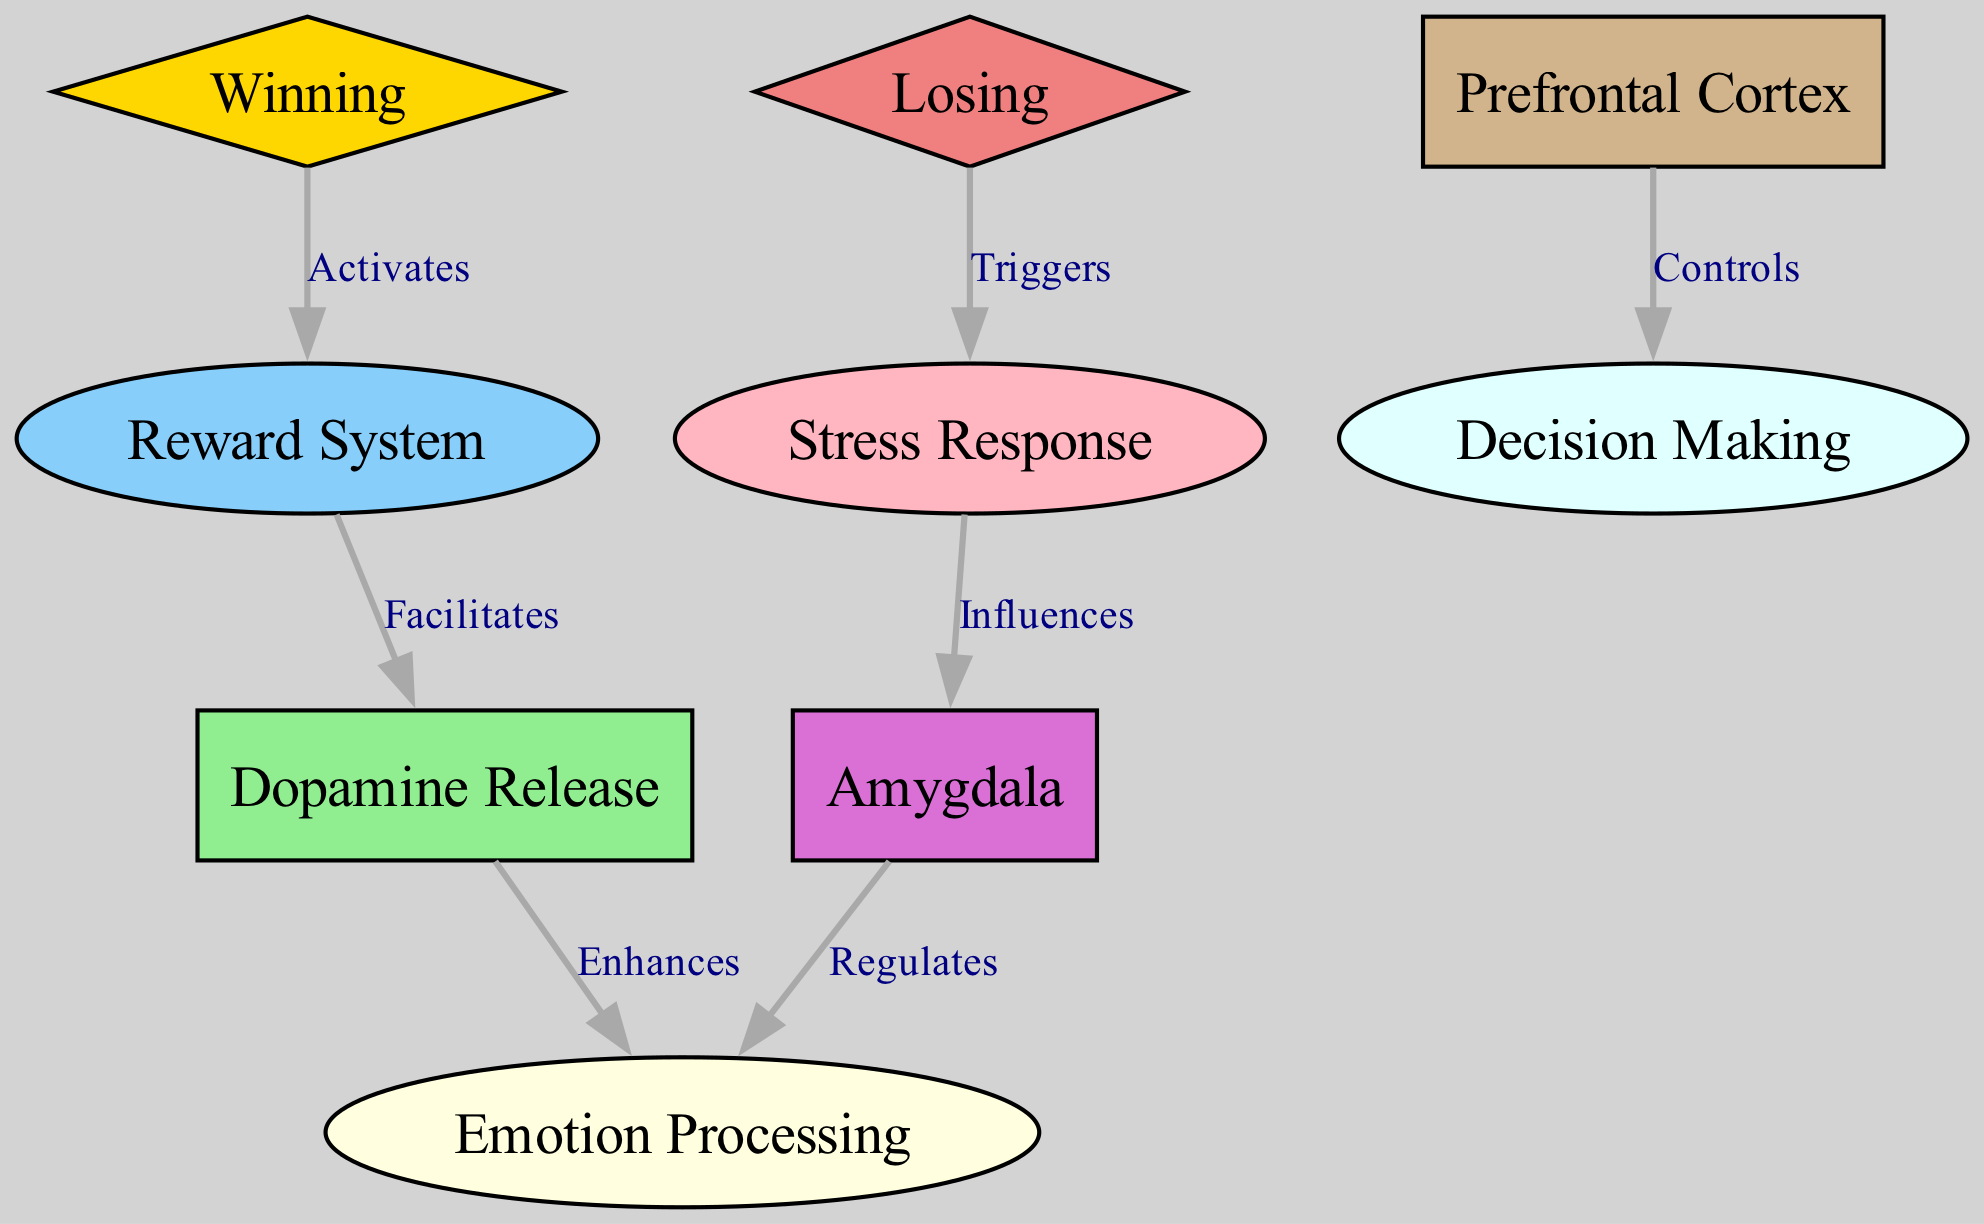What is the connection from winning to another node? The diagram shows that "Winning" activates the "Reward System." This is indicated by the directed edge labeled "Activates" going from "win" to "reward_system."
Answer: Reward System How many nodes are present in the diagram? The diagram consists of 9 distinct nodes, which include the different brain areas and responses related to winning and losing in poker.
Answer: 9 Which area regulates emotion processing? According to the diagram, the "Amygdala" regulates "Emotion Processing." This is evidenced by the edge labeled "Regulates" going from "amygdala" to "emotion_processing."
Answer: Amygdala What triggers a stress response according to the diagram? The diagram details that "Losing" triggers a "Stress Response." This is shown by the edge labeled "Triggers" originating from "lose" and pointing to "stress_response."
Answer: Stress Response Which node enhances dopamine release? The diagram indicates that "Dopamine Release" is enhanced by another node. Specifically, "Dopamine Release" enhances "Emotion Processing" as per the edge labeled "Enhances" connecting them.
Answer: Emotion Processing What is the influence of the stress response on another brain region? The diagram shows that the "Stress Response" influences the "Amygdala." This relationship is highlighted by the edge labeled "Influences" from "stress_response" to "amygdala."
Answer: Amygdala What role does the prefrontal cortex have in this diagram? The "Prefrontal Cortex" controls "Decision Making," as illustrated by the labeled directed edge from "prefrontal_cortex" to "decision_making."
Answer: Decision Making How does the reward system affect dopamine release? The diagram indicates that the "Reward System" facilitates "Dopamine Release." This is demonstrated by the connection labeled "Facilitates" pointing from "reward_system" to "dopamine_release."
Answer: Dopamine Release What is the color of the winning node? The "Winning" node is depicted in gold, which is specified in the diagram's custom node styles for "win."
Answer: Gold 